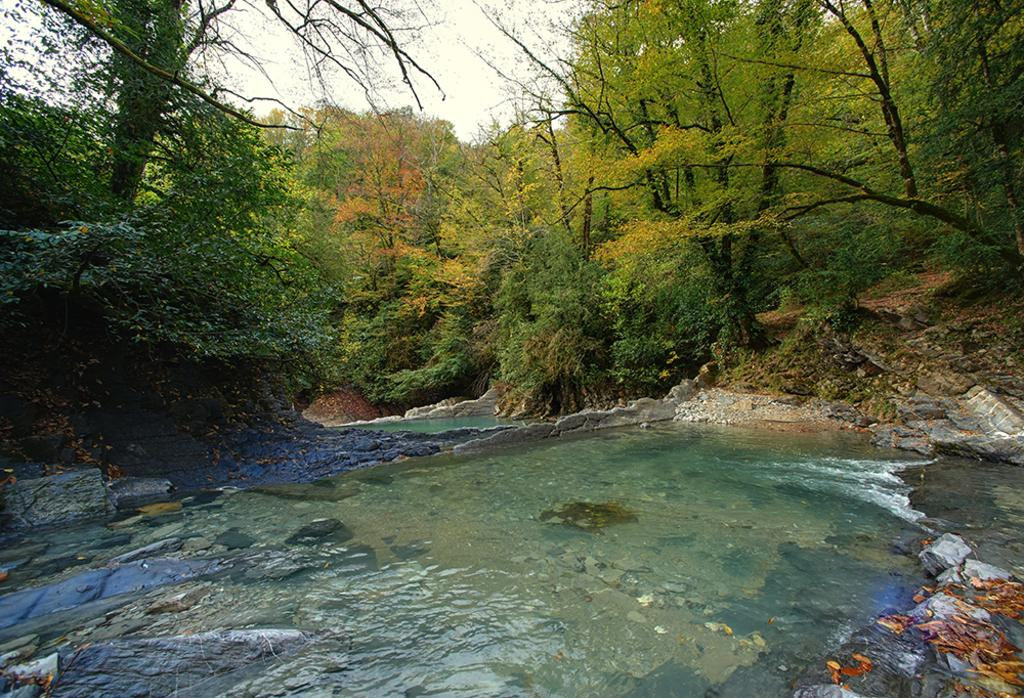What is the main feature in the foreground of the image? There is a river in the foreground of the image. What type of vegetation can be seen near the river? Trees are present on either side of the river. What is visible at the top of the image? The sky is visible at the top of the image. Can you see any fights happening in the image? There is no fight present in the image; it features a river with trees on either side and a visible sky. What type of frame is used to display the image? The provided facts do not mention the type of frame used to display the image, so it cannot be determined from the information given. 